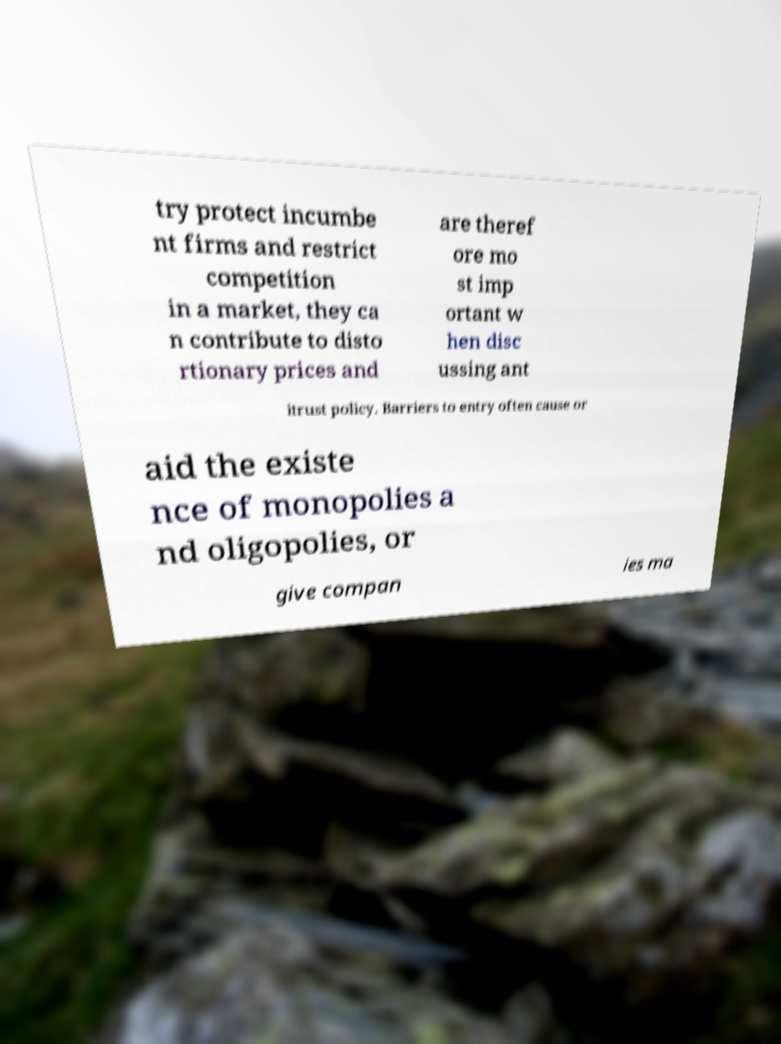Please identify and transcribe the text found in this image. try protect incumbe nt firms and restrict competition in a market, they ca n contribute to disto rtionary prices and are theref ore mo st imp ortant w hen disc ussing ant itrust policy. Barriers to entry often cause or aid the existe nce of monopolies a nd oligopolies, or give compan ies ma 